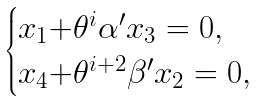Convert formula to latex. <formula><loc_0><loc_0><loc_500><loc_500>\begin{cases} x _ { 1 } { + } \theta ^ { i } \alpha ^ { \prime } x _ { 3 } = 0 , \\ x _ { 4 } { + } \theta ^ { i { + } 2 } \beta ^ { \prime } x _ { 2 } = 0 , \end{cases}</formula> 